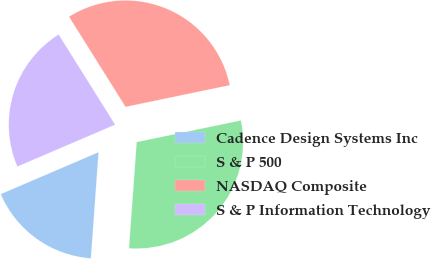Convert chart. <chart><loc_0><loc_0><loc_500><loc_500><pie_chart><fcel>Cadence Design Systems Inc<fcel>S & P 500<fcel>NASDAQ Composite<fcel>S & P Information Technology<nl><fcel>17.41%<fcel>29.41%<fcel>30.65%<fcel>22.53%<nl></chart> 